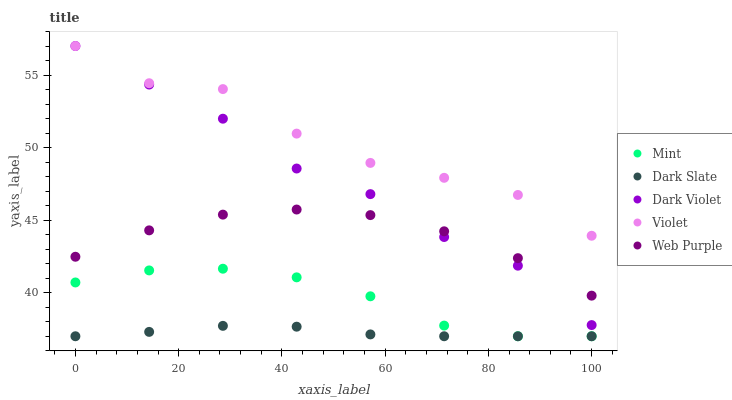Does Dark Slate have the minimum area under the curve?
Answer yes or no. Yes. Does Violet have the maximum area under the curve?
Answer yes or no. Yes. Does Web Purple have the minimum area under the curve?
Answer yes or no. No. Does Web Purple have the maximum area under the curve?
Answer yes or no. No. Is Dark Slate the smoothest?
Answer yes or no. Yes. Is Violet the roughest?
Answer yes or no. Yes. Is Web Purple the smoothest?
Answer yes or no. No. Is Web Purple the roughest?
Answer yes or no. No. Does Dark Slate have the lowest value?
Answer yes or no. Yes. Does Web Purple have the lowest value?
Answer yes or no. No. Does Violet have the highest value?
Answer yes or no. Yes. Does Web Purple have the highest value?
Answer yes or no. No. Is Mint less than Web Purple?
Answer yes or no. Yes. Is Violet greater than Dark Slate?
Answer yes or no. Yes. Does Dark Slate intersect Mint?
Answer yes or no. Yes. Is Dark Slate less than Mint?
Answer yes or no. No. Is Dark Slate greater than Mint?
Answer yes or no. No. Does Mint intersect Web Purple?
Answer yes or no. No. 